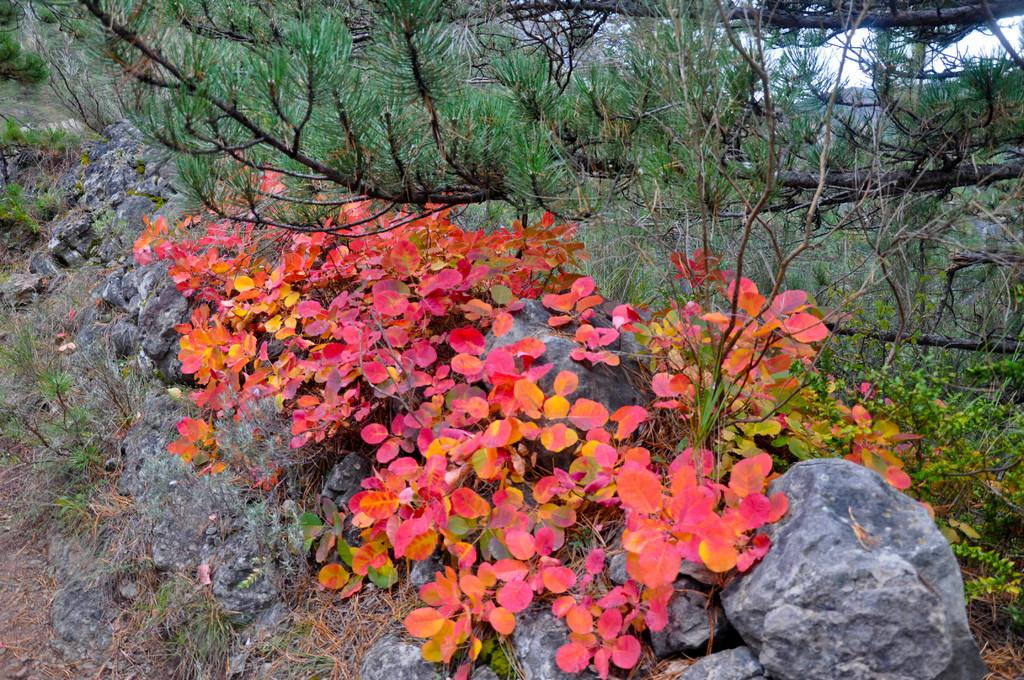What type of vegetation can be seen in the image? There are trees and plants in the image. What other natural elements are present in the image? There are rocks in the image. What is visible at the top of the image? The sky is visible at the top of the image. How many girls are holding quills under the shade of the trees in the image? There are no girls or quills present in the image; it features trees, plants, rocks, and the sky. 